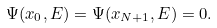Convert formula to latex. <formula><loc_0><loc_0><loc_500><loc_500>\Psi ( x _ { 0 } , E ) = \Psi ( x _ { N + 1 } , E ) = 0 .</formula> 